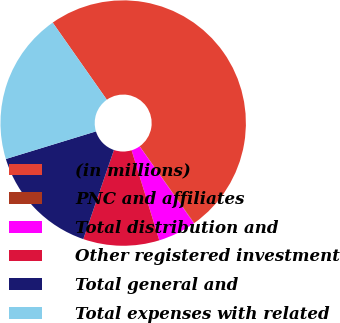Convert chart to OTSL. <chart><loc_0><loc_0><loc_500><loc_500><pie_chart><fcel>(in millions)<fcel>PNC and affiliates<fcel>Total distribution and<fcel>Other registered investment<fcel>Total general and<fcel>Total expenses with related<nl><fcel>49.9%<fcel>0.05%<fcel>5.03%<fcel>10.02%<fcel>15.0%<fcel>19.99%<nl></chart> 